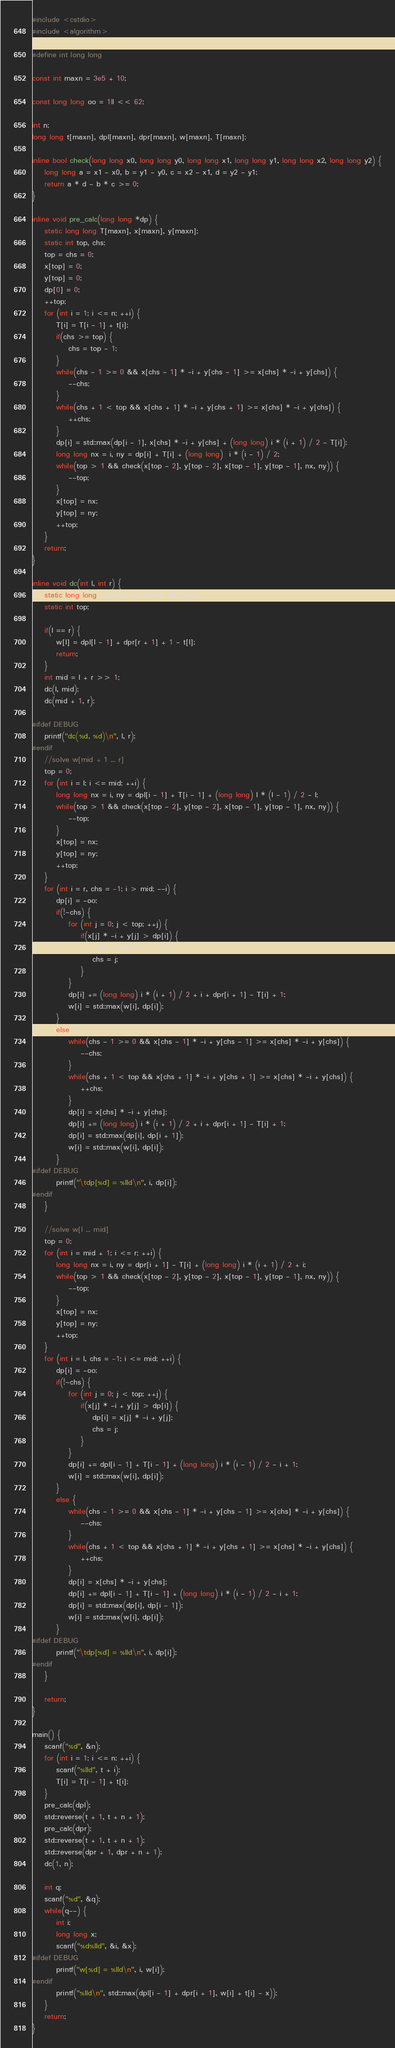<code> <loc_0><loc_0><loc_500><loc_500><_C++_>#include <cstdio>
#include <algorithm>

#define int long long

const int maxn = 3e5 + 10;

const long long oo = 1ll << 62;

int n;
long long t[maxn], dpl[maxn], dpr[maxn], w[maxn], T[maxn];

inline bool check(long long x0, long long y0, long long x1, long long y1, long long x2, long long y2) {
	long long a = x1 - x0, b = y1 - y0, c = x2 - x1, d = y2 - y1;
	return a * d - b * c >= 0;
}

inline void pre_calc(long long *dp) {
	static long long T[maxn], x[maxn], y[maxn];
	static int top, chs;
	top = chs = 0;
	x[top] = 0;
	y[top] = 0;
	dp[0] = 0;
	++top;
	for (int i = 1; i <= n; ++i) {
		T[i] = T[i - 1] + t[i];
		if(chs >= top) {
			chs = top - 1;
		}
		while(chs - 1 >= 0 && x[chs - 1] * -i + y[chs - 1] >= x[chs] * -i + y[chs]) {
			--chs;
		}
		while(chs + 1 < top && x[chs + 1] * -i + y[chs + 1] >= x[chs] * -i + y[chs]) {
			++chs;
		}
		dp[i] = std::max(dp[i - 1], x[chs] * -i + y[chs] + (long long) i * (i + 1) / 2 - T[i]);
		long long nx = i, ny = dp[i] + T[i] + (long long)  i * (i - 1) / 2;
		while(top > 1 && check(x[top - 2], y[top - 2], x[top - 1], y[top - 1], nx, ny)) {
			--top;
		}
		x[top] = nx;
		y[top] = ny;
		++top;
	}
	return;
}

inline void dc(int l, int r) {
	static long long x[maxn], y[maxn], dp[maxn];
	static int top;

	if(l == r) {
		w[l] = dpl[l - 1] + dpr[r + 1] + 1 - t[l];
		return;
	}
	int mid = l + r >> 1;
	dc(l, mid);
	dc(mid + 1, r);

#ifdef DEBUG
	printf("dc(%d, %d)\n", l, r);
#endif
	//solve w[mid + 1 ... r]
	top = 0;
	for (int i = l; i <= mid; ++i) {
		long long nx = i, ny = dpl[i - 1] + T[i - 1] + (long long) l * (l - 1) / 2 - l;
		while(top > 1 && check(x[top - 2], y[top - 2], x[top - 1], y[top - 1], nx, ny)) {
			--top;
		}
		x[top] = nx;
		y[top] = ny;
		++top;
	}
	for (int i = r, chs = -1; i > mid; --i) {
		dp[i] = -oo;
		if(!~chs) {
			for (int j = 0; j < top; ++j) {
				if(x[j] * -i + y[j] > dp[i]) {
					dp[i] = x[j] * -i + y[j];
					chs = j;
				}
			}
			dp[i] += (long long) i * (i + 1) / 2 + i + dpr[i + 1] - T[i] + 1;
			w[i] = std::max(w[i], dp[i]);
		}
		else {
			while(chs - 1 >= 0 && x[chs - 1] * -i + y[chs - 1] >= x[chs] * -i + y[chs]) {
				--chs;
			}
			while(chs + 1 < top && x[chs + 1] * -i + y[chs + 1] >= x[chs] * -i + y[chs]) {
				++chs;
			}
			dp[i] = x[chs] * -i + y[chs];
			dp[i] += (long long) i * (i + 1) / 2 + i + dpr[i + 1] - T[i] + 1;
			dp[i] = std::max(dp[i], dp[i + 1]);
			w[i] = std::max(w[i], dp[i]);
		}
#ifdef DEBUG
		printf("\tdp[%d] = %lld\n", i, dp[i]);
#endif
	}

	//solve w[l ... mid]
	top = 0;
	for (int i = mid + 1; i <= r; ++i) {
		long long nx = i, ny = dpr[i + 1] - T[i] + (long long) i * (i + 1) / 2 + i;
		while(top > 1 && check(x[top - 2], y[top - 2], x[top - 1], y[top - 1], nx, ny)) {
			--top;
		}
		x[top] = nx;
		y[top] = ny;
		++top;
	}
	for (int i = l, chs = -1; i <= mid; ++i) {
		dp[i] = -oo;
		if(!~chs) {
			for (int j = 0; j < top; ++j) {
				if(x[j] * -i + y[j] > dp[i]) {
					dp[i] = x[j] * -i + y[j];
					chs = j;
				}
			}
			dp[i] += dpl[i - 1] + T[i - 1] + (long long) i * (i - 1) / 2 - i + 1;
			w[i] = std::max(w[i], dp[i]);
		}
		else {
			while(chs - 1 >= 0 && x[chs - 1] * -i + y[chs - 1] >= x[chs] * -i + y[chs]) {
				--chs;
			}
			while(chs + 1 < top && x[chs + 1] * -i + y[chs + 1] >= x[chs] * -i + y[chs]) {
				++chs;
			}
			dp[i] = x[chs] * -i + y[chs];
			dp[i] += dpl[i - 1] + T[i - 1] + (long long) i * (i - 1) / 2 - i + 1;
			dp[i] = std::max(dp[i], dp[i - 1]);
			w[i] = std::max(w[i], dp[i]);
		}
#ifdef DEBUG
		printf("\tdp[%d] = %lld\n", i, dp[i]);
#endif
	}

	return;
}

main() {
	scanf("%d", &n);
	for (int i = 1; i <= n; ++i) {
		scanf("%lld", t + i);
		T[i] = T[i - 1] + t[i];
	}
	pre_calc(dpl);
	std::reverse(t + 1, t + n + 1);
	pre_calc(dpr);
	std::reverse(t + 1, t + n + 1);
	std::reverse(dpr + 1, dpr + n + 1);
	dc(1, n);

	int q;
	scanf("%d", &q);
	while(q--) {
		int i;
		long long x;
		scanf("%d%lld", &i, &x);
#ifdef DEBUG
		printf("w[%d] = %lld\n", i, w[i]);
#endif
		printf("%lld\n", std::max(dpl[i - 1] + dpr[i + 1], w[i] + t[i] - x));
	}
	return;
}
</code> 